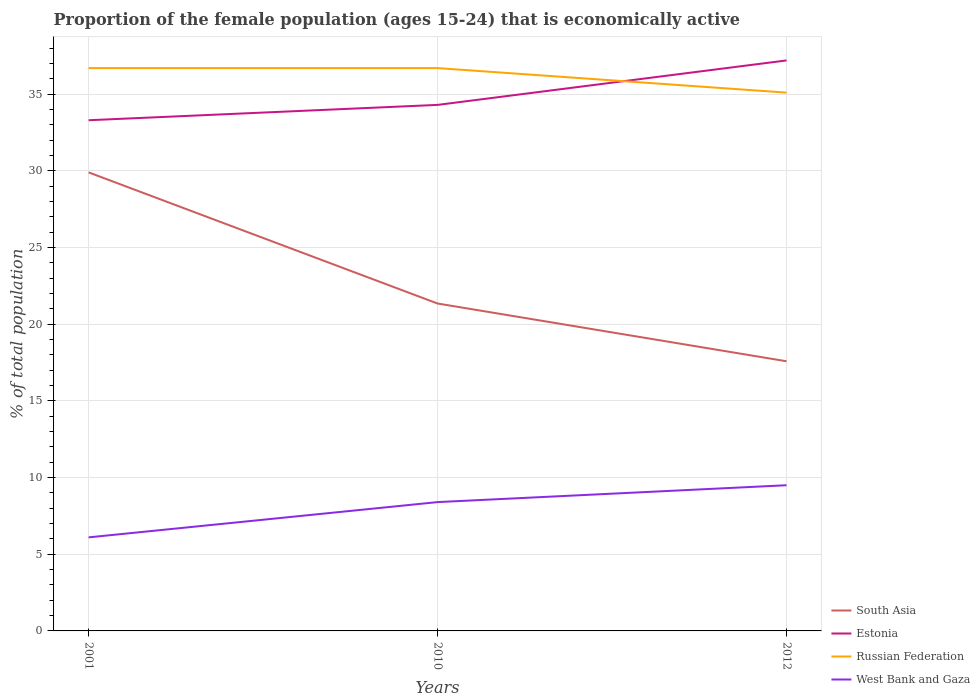Across all years, what is the maximum proportion of the female population that is economically active in Russian Federation?
Your answer should be very brief. 35.1. What is the total proportion of the female population that is economically active in Estonia in the graph?
Give a very brief answer. -3.9. What is the difference between the highest and the second highest proportion of the female population that is economically active in Estonia?
Ensure brevity in your answer.  3.9. What is the difference between the highest and the lowest proportion of the female population that is economically active in Russian Federation?
Keep it short and to the point. 2. How many lines are there?
Make the answer very short. 4. Are the values on the major ticks of Y-axis written in scientific E-notation?
Your answer should be compact. No. Does the graph contain any zero values?
Keep it short and to the point. No. Where does the legend appear in the graph?
Provide a succinct answer. Bottom right. How are the legend labels stacked?
Make the answer very short. Vertical. What is the title of the graph?
Your response must be concise. Proportion of the female population (ages 15-24) that is economically active. What is the label or title of the X-axis?
Make the answer very short. Years. What is the label or title of the Y-axis?
Your answer should be compact. % of total population. What is the % of total population in South Asia in 2001?
Provide a short and direct response. 29.9. What is the % of total population of Estonia in 2001?
Keep it short and to the point. 33.3. What is the % of total population in Russian Federation in 2001?
Make the answer very short. 36.7. What is the % of total population in West Bank and Gaza in 2001?
Ensure brevity in your answer.  6.1. What is the % of total population in South Asia in 2010?
Provide a succinct answer. 21.35. What is the % of total population in Estonia in 2010?
Keep it short and to the point. 34.3. What is the % of total population of Russian Federation in 2010?
Your answer should be very brief. 36.7. What is the % of total population of West Bank and Gaza in 2010?
Make the answer very short. 8.4. What is the % of total population in South Asia in 2012?
Keep it short and to the point. 17.58. What is the % of total population in Estonia in 2012?
Make the answer very short. 37.2. What is the % of total population in Russian Federation in 2012?
Ensure brevity in your answer.  35.1. What is the % of total population of West Bank and Gaza in 2012?
Give a very brief answer. 9.5. Across all years, what is the maximum % of total population in South Asia?
Your answer should be compact. 29.9. Across all years, what is the maximum % of total population of Estonia?
Offer a terse response. 37.2. Across all years, what is the maximum % of total population in Russian Federation?
Offer a very short reply. 36.7. Across all years, what is the maximum % of total population of West Bank and Gaza?
Your answer should be very brief. 9.5. Across all years, what is the minimum % of total population of South Asia?
Your response must be concise. 17.58. Across all years, what is the minimum % of total population of Estonia?
Ensure brevity in your answer.  33.3. Across all years, what is the minimum % of total population of Russian Federation?
Offer a terse response. 35.1. Across all years, what is the minimum % of total population of West Bank and Gaza?
Ensure brevity in your answer.  6.1. What is the total % of total population of South Asia in the graph?
Make the answer very short. 68.83. What is the total % of total population of Estonia in the graph?
Give a very brief answer. 104.8. What is the total % of total population in Russian Federation in the graph?
Your answer should be very brief. 108.5. What is the total % of total population in West Bank and Gaza in the graph?
Make the answer very short. 24. What is the difference between the % of total population of South Asia in 2001 and that in 2010?
Your response must be concise. 8.55. What is the difference between the % of total population of Russian Federation in 2001 and that in 2010?
Give a very brief answer. 0. What is the difference between the % of total population of West Bank and Gaza in 2001 and that in 2010?
Your response must be concise. -2.3. What is the difference between the % of total population of South Asia in 2001 and that in 2012?
Provide a short and direct response. 12.32. What is the difference between the % of total population in Estonia in 2001 and that in 2012?
Offer a terse response. -3.9. What is the difference between the % of total population in Russian Federation in 2001 and that in 2012?
Offer a terse response. 1.6. What is the difference between the % of total population of South Asia in 2010 and that in 2012?
Your answer should be very brief. 3.77. What is the difference between the % of total population in South Asia in 2001 and the % of total population in Russian Federation in 2010?
Keep it short and to the point. -6.8. What is the difference between the % of total population of Estonia in 2001 and the % of total population of West Bank and Gaza in 2010?
Keep it short and to the point. 24.9. What is the difference between the % of total population of Russian Federation in 2001 and the % of total population of West Bank and Gaza in 2010?
Provide a short and direct response. 28.3. What is the difference between the % of total population in South Asia in 2001 and the % of total population in Russian Federation in 2012?
Offer a very short reply. -5.2. What is the difference between the % of total population of South Asia in 2001 and the % of total population of West Bank and Gaza in 2012?
Provide a short and direct response. 20.4. What is the difference between the % of total population of Estonia in 2001 and the % of total population of Russian Federation in 2012?
Offer a very short reply. -1.8. What is the difference between the % of total population of Estonia in 2001 and the % of total population of West Bank and Gaza in 2012?
Your answer should be very brief. 23.8. What is the difference between the % of total population in Russian Federation in 2001 and the % of total population in West Bank and Gaza in 2012?
Your answer should be compact. 27.2. What is the difference between the % of total population of South Asia in 2010 and the % of total population of Estonia in 2012?
Provide a short and direct response. -15.85. What is the difference between the % of total population of South Asia in 2010 and the % of total population of Russian Federation in 2012?
Keep it short and to the point. -13.75. What is the difference between the % of total population in South Asia in 2010 and the % of total population in West Bank and Gaza in 2012?
Give a very brief answer. 11.85. What is the difference between the % of total population in Estonia in 2010 and the % of total population in Russian Federation in 2012?
Make the answer very short. -0.8. What is the difference between the % of total population in Estonia in 2010 and the % of total population in West Bank and Gaza in 2012?
Provide a succinct answer. 24.8. What is the difference between the % of total population of Russian Federation in 2010 and the % of total population of West Bank and Gaza in 2012?
Provide a succinct answer. 27.2. What is the average % of total population in South Asia per year?
Keep it short and to the point. 22.94. What is the average % of total population of Estonia per year?
Your response must be concise. 34.93. What is the average % of total population in Russian Federation per year?
Provide a short and direct response. 36.17. In the year 2001, what is the difference between the % of total population in South Asia and % of total population in Russian Federation?
Your response must be concise. -6.8. In the year 2001, what is the difference between the % of total population of South Asia and % of total population of West Bank and Gaza?
Your response must be concise. 23.8. In the year 2001, what is the difference between the % of total population of Estonia and % of total population of West Bank and Gaza?
Give a very brief answer. 27.2. In the year 2001, what is the difference between the % of total population of Russian Federation and % of total population of West Bank and Gaza?
Make the answer very short. 30.6. In the year 2010, what is the difference between the % of total population of South Asia and % of total population of Estonia?
Ensure brevity in your answer.  -12.95. In the year 2010, what is the difference between the % of total population of South Asia and % of total population of Russian Federation?
Your answer should be very brief. -15.35. In the year 2010, what is the difference between the % of total population of South Asia and % of total population of West Bank and Gaza?
Keep it short and to the point. 12.95. In the year 2010, what is the difference between the % of total population in Estonia and % of total population in Russian Federation?
Keep it short and to the point. -2.4. In the year 2010, what is the difference between the % of total population in Estonia and % of total population in West Bank and Gaza?
Your answer should be compact. 25.9. In the year 2010, what is the difference between the % of total population of Russian Federation and % of total population of West Bank and Gaza?
Give a very brief answer. 28.3. In the year 2012, what is the difference between the % of total population of South Asia and % of total population of Estonia?
Give a very brief answer. -19.62. In the year 2012, what is the difference between the % of total population in South Asia and % of total population in Russian Federation?
Ensure brevity in your answer.  -17.52. In the year 2012, what is the difference between the % of total population in South Asia and % of total population in West Bank and Gaza?
Make the answer very short. 8.08. In the year 2012, what is the difference between the % of total population of Estonia and % of total population of West Bank and Gaza?
Provide a short and direct response. 27.7. In the year 2012, what is the difference between the % of total population of Russian Federation and % of total population of West Bank and Gaza?
Ensure brevity in your answer.  25.6. What is the ratio of the % of total population of South Asia in 2001 to that in 2010?
Provide a succinct answer. 1.4. What is the ratio of the % of total population of Estonia in 2001 to that in 2010?
Provide a succinct answer. 0.97. What is the ratio of the % of total population in Russian Federation in 2001 to that in 2010?
Provide a short and direct response. 1. What is the ratio of the % of total population in West Bank and Gaza in 2001 to that in 2010?
Your answer should be very brief. 0.73. What is the ratio of the % of total population in South Asia in 2001 to that in 2012?
Your answer should be very brief. 1.7. What is the ratio of the % of total population of Estonia in 2001 to that in 2012?
Offer a terse response. 0.9. What is the ratio of the % of total population in Russian Federation in 2001 to that in 2012?
Ensure brevity in your answer.  1.05. What is the ratio of the % of total population of West Bank and Gaza in 2001 to that in 2012?
Make the answer very short. 0.64. What is the ratio of the % of total population in South Asia in 2010 to that in 2012?
Your response must be concise. 1.21. What is the ratio of the % of total population in Estonia in 2010 to that in 2012?
Make the answer very short. 0.92. What is the ratio of the % of total population of Russian Federation in 2010 to that in 2012?
Make the answer very short. 1.05. What is the ratio of the % of total population in West Bank and Gaza in 2010 to that in 2012?
Ensure brevity in your answer.  0.88. What is the difference between the highest and the second highest % of total population of South Asia?
Offer a terse response. 8.55. What is the difference between the highest and the second highest % of total population of Estonia?
Offer a very short reply. 2.9. What is the difference between the highest and the second highest % of total population in Russian Federation?
Your answer should be compact. 0. What is the difference between the highest and the second highest % of total population in West Bank and Gaza?
Your response must be concise. 1.1. What is the difference between the highest and the lowest % of total population of South Asia?
Provide a short and direct response. 12.32. 